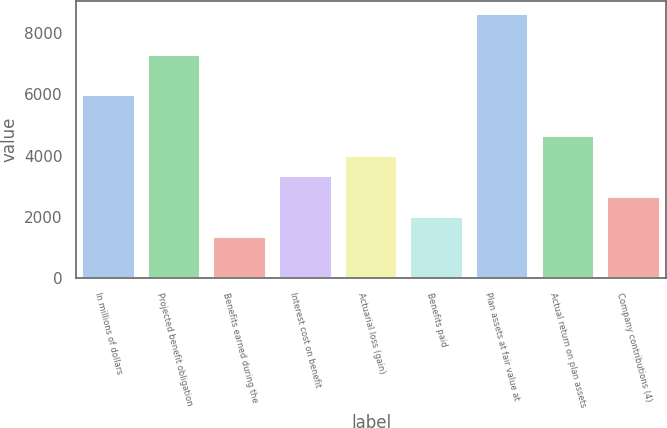Convert chart to OTSL. <chart><loc_0><loc_0><loc_500><loc_500><bar_chart><fcel>In millions of dollars<fcel>Projected benefit obligation<fcel>Benefits earned during the<fcel>Interest cost on benefit<fcel>Actuarial loss (gain)<fcel>Benefits paid<fcel>Plan assets at fair value at<fcel>Actual return on plan assets<fcel>Company contributions (4)<nl><fcel>5968.8<fcel>7289.2<fcel>1347.4<fcel>3328<fcel>3988.2<fcel>2007.6<fcel>8609.6<fcel>4648.4<fcel>2667.8<nl></chart> 